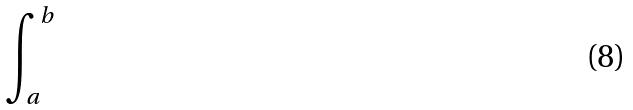Convert formula to latex. <formula><loc_0><loc_0><loc_500><loc_500>\int _ { a } ^ { b }</formula> 